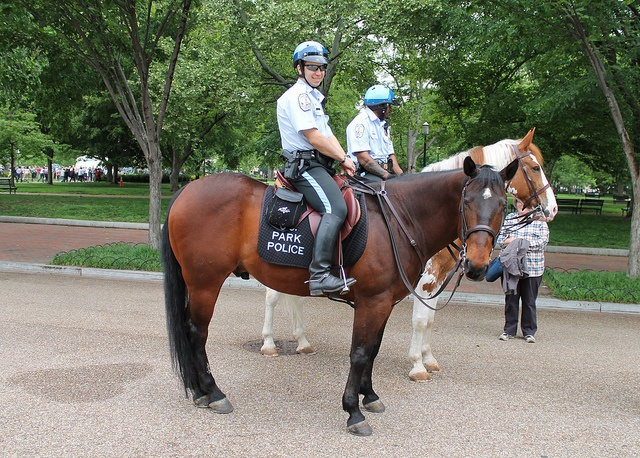Describe the objects in this image and their specific colors. I can see horse in black, maroon, gray, and brown tones, people in black, white, and gray tones, horse in black, lightgray, darkgray, gray, and tan tones, people in black, darkgray, gray, and lightgray tones, and people in black, white, gray, and lightblue tones in this image. 